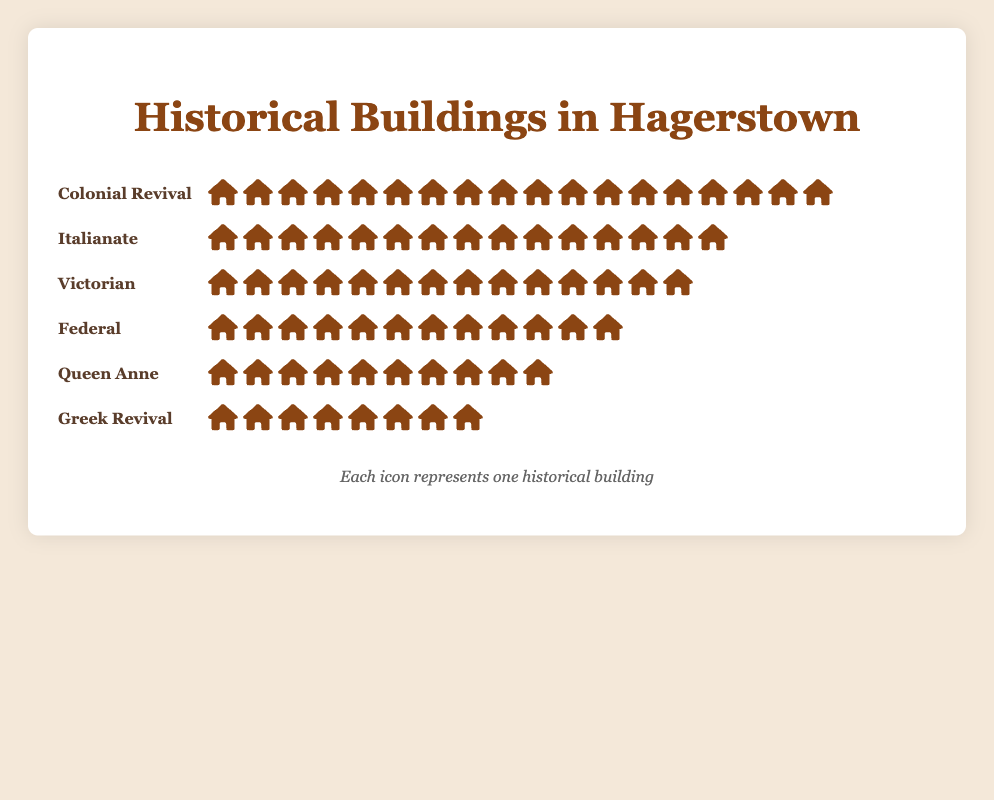How many historical buildings in Hagerstown are in the Queen Anne architectural style? Look at the row labeled "Queen Anne" and count the number of house icons displayed.
Answer: 10 Which architectural style has the most buildings? Identify the row with the highest number of house icons. The "Colonial Revival" style has 18 buildings, which is the highest.
Answer: Colonial Revival How many more Italianate buildings are there compared to Greek Revival buildings? Count the house icons in both the "Italianate" (15 icons) and "Greek Revival" (8 icons) rows and find the difference: 15 - 8.
Answer: 7 What is the total number of historical buildings shown in the figure? Sum the number of house icons from all the architectural styles: 12 (Federal) + 8 (Greek Revival) + 15 (Italianate) + 10 (Queen Anne) + 18 (Colonial Revival) + 14 (Victorian).
Answer: 77 Which two architectural styles have the closest number of buildings? Compare the counts of house icons for all styles, looking for the smallest difference. "Federal" (12) and "Queen Anne" (10) have a difference of 2, which is the smallest.
Answer: Federal and Queen Anne What percentage of the total buildings is in the Colonial Revival style? First, calculate the total number of buildings (77). Then, divide the number of Colonial Revival buildings (18) by the total number and multiply by 100 to get the percentage: (18 / 77) * 100.
Answer: ~23.4% Are there more Victorian or Federal buildings? Compare the number of house icons in the "Victorian" (14) and "Federal" (12) rows. Victorian has more.
Answer: Victorian How many styles have fewer than 15 buildings? Count the number of styles with fewer than 15 house icons. "Federal" (12), "Greek Revival" (8), and "Queen Anne" (10) are all under 15.
Answer: 3 What's the average number of buildings per architectural style? Sum the number of buildings for all styles (77) and divide by the number of styles (6): 77 / 6.
Answer: ~12.8 